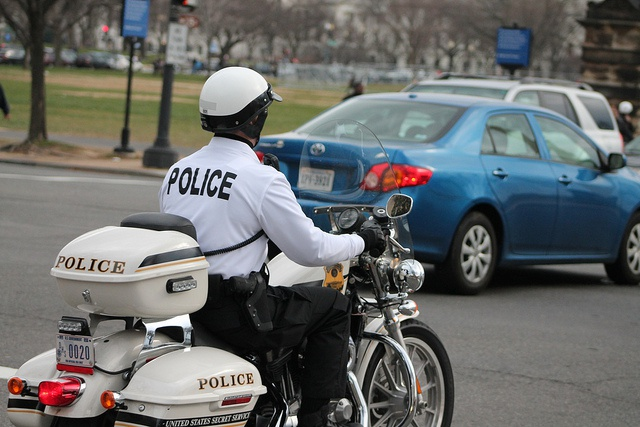Describe the objects in this image and their specific colors. I can see motorcycle in black, darkgray, gray, and lightgray tones, car in black, gray, darkblue, and darkgray tones, people in black, lavender, and darkgray tones, truck in black, darkgray, lightgray, and gray tones, and car in black, darkgray, lightgray, and gray tones in this image. 